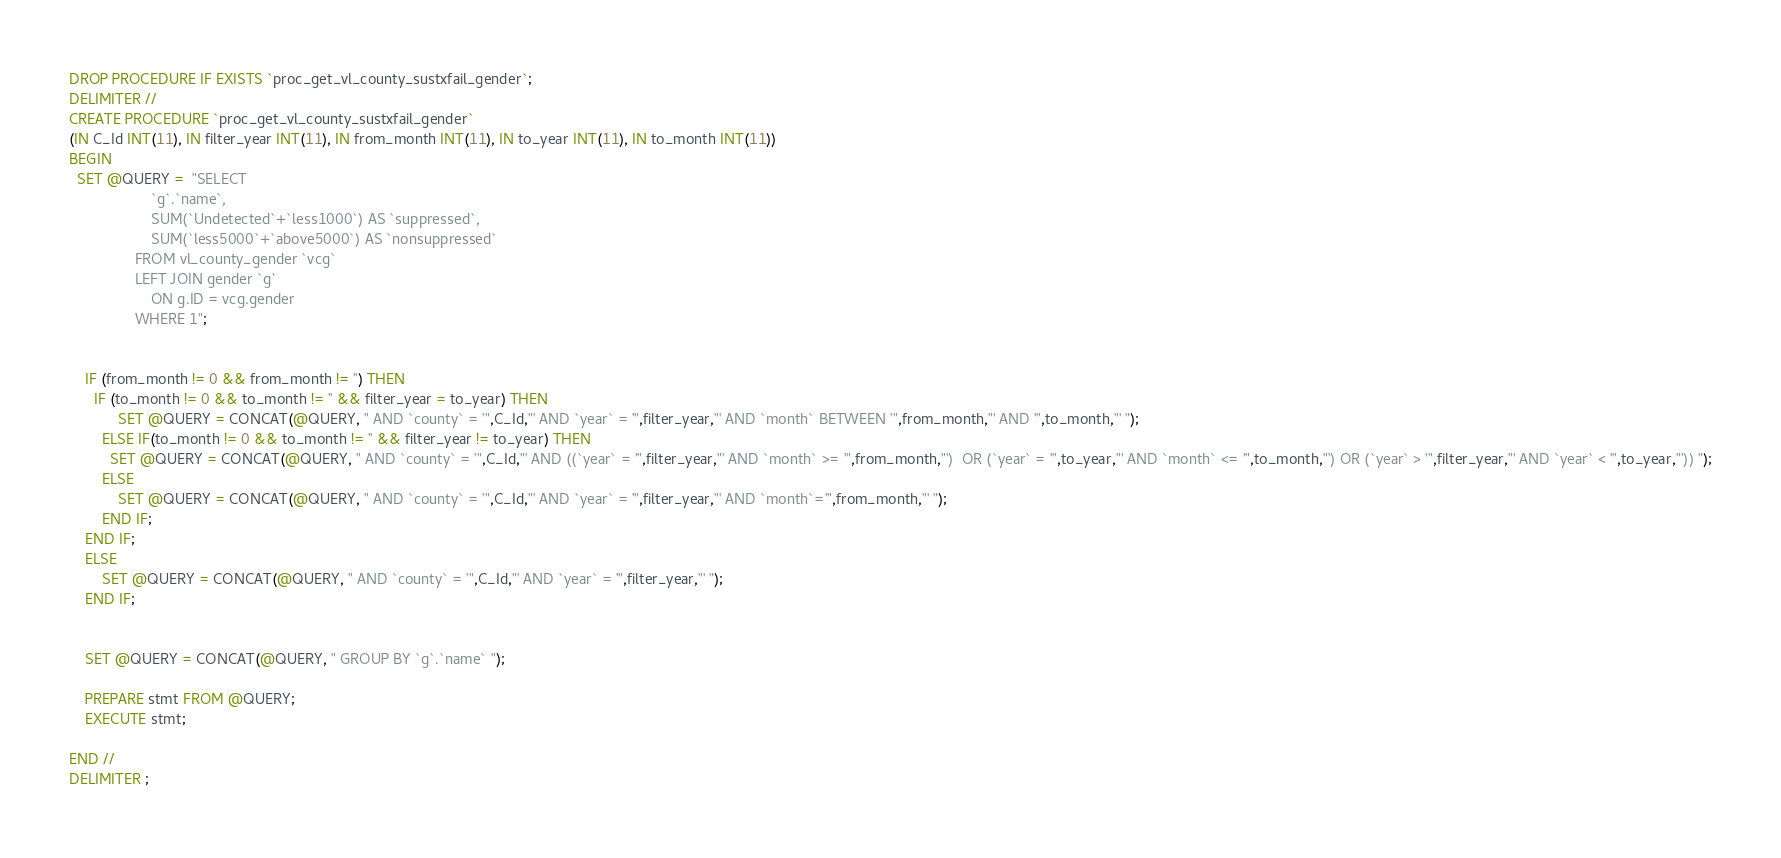Convert code to text. <code><loc_0><loc_0><loc_500><loc_500><_SQL_>DROP PROCEDURE IF EXISTS `proc_get_vl_county_sustxfail_gender`;
DELIMITER //
CREATE PROCEDURE `proc_get_vl_county_sustxfail_gender`
(IN C_Id INT(11), IN filter_year INT(11), IN from_month INT(11), IN to_year INT(11), IN to_month INT(11))
BEGIN
  SET @QUERY =  "SELECT 
                    `g`.`name`,
                    SUM(`Undetected`+`less1000`) AS `suppressed`,
                    SUM(`less5000`+`above5000`) AS `nonsuppressed`
                FROM vl_county_gender `vcg`
                LEFT JOIN gender `g`
                    ON g.ID = vcg.gender 
                WHERE 1";

  
    IF (from_month != 0 && from_month != '') THEN
      IF (to_month != 0 && to_month != '' && filter_year = to_year) THEN
            SET @QUERY = CONCAT(@QUERY, " AND `county` = '",C_Id,"' AND `year` = '",filter_year,"' AND `month` BETWEEN '",from_month,"' AND '",to_month,"' ");
        ELSE IF(to_month != 0 && to_month != '' && filter_year != to_year) THEN
          SET @QUERY = CONCAT(@QUERY, " AND `county` = '",C_Id,"' AND ((`year` = '",filter_year,"' AND `month` >= '",from_month,"')  OR (`year` = '",to_year,"' AND `month` <= '",to_month,"') OR (`year` > '",filter_year,"' AND `year` < '",to_year,"')) ");
        ELSE
            SET @QUERY = CONCAT(@QUERY, " AND `county` = '",C_Id,"' AND `year` = '",filter_year,"' AND `month`='",from_month,"' ");
        END IF;
    END IF;
    ELSE
        SET @QUERY = CONCAT(@QUERY, " AND `county` = '",C_Id,"' AND `year` = '",filter_year,"' ");
    END IF;


    SET @QUERY = CONCAT(@QUERY, " GROUP BY `g`.`name` ");

    PREPARE stmt FROM @QUERY;
    EXECUTE stmt;
    
END //
DELIMITER ;
</code> 